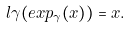Convert formula to latex. <formula><loc_0><loc_0><loc_500><loc_500>l \gamma ( e x p _ { \gamma } ( x ) ) = x .</formula> 